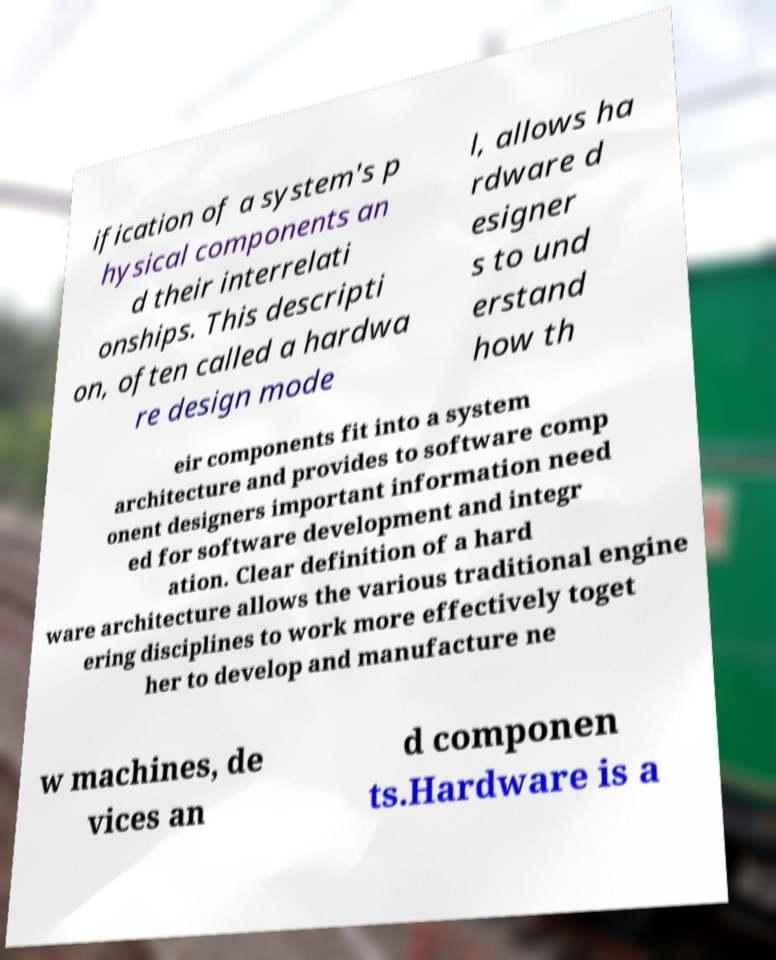For documentation purposes, I need the text within this image transcribed. Could you provide that? ification of a system's p hysical components an d their interrelati onships. This descripti on, often called a hardwa re design mode l, allows ha rdware d esigner s to und erstand how th eir components fit into a system architecture and provides to software comp onent designers important information need ed for software development and integr ation. Clear definition of a hard ware architecture allows the various traditional engine ering disciplines to work more effectively toget her to develop and manufacture ne w machines, de vices an d componen ts.Hardware is a 